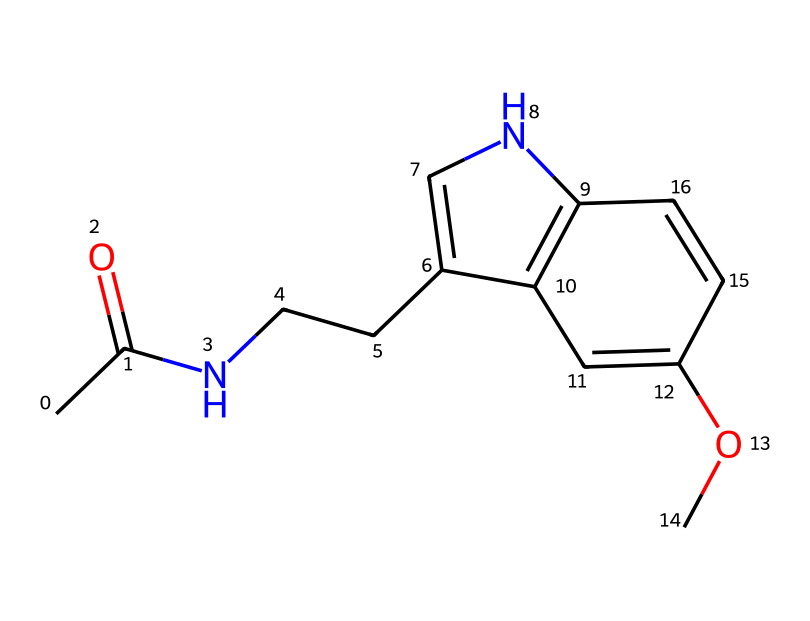How many rings are present in this chemical structure? The chemical structure shows two distinct rings in the molecular framework. By examining the SMILES representation, it reveals that there are connections that form two cyclic structures.
Answer: 2 What is the primary functional group in this molecule? Analyzing the structure indicates the presence of an amide functional group, which is characterized by a carbonyl group connected to a nitrogen atom. In the SMILES notation, the 'N' indicates the nitrogen involved in the amide bond, confirming its presence.
Answer: amide How many carbon atoms are in this molecule? Counting the 'C' characters in the SMILES shows there are a total of 13 carbon atoms present. This includes all carbon atoms in the rings and those outside them, accurately reflecting the molecular composition.
Answer: 13 What part of this molecule is responsible for light sensitivity? The presence of the carbonyl group and the specific ring structure are critical for the molecule's interaction with light, enabling melatonin's photoperiodic signaling role. The carbonyl is essential for conformational changes in response to light.
Answer: carbonyl group What is the molecular formula of melatonin as derived from the structure? By analyzing the number of each type of atom from the SMILES, we derive the molecular formula C13H16N2O2, considering all carbon, hydrogen, nitrogen, and oxygen atoms present in the chemical structure.
Answer: C13H16N2O2 How does the presence of nitrogen affect this hormone's function? The nitrogen atom in the amide group is critical for the molecule's biological activity, affecting how melatonin binds to receptors in the brain that regulate sleep and circadian rhythms, indicating its role as a signaling molecule.
Answer: it enables receptor binding 